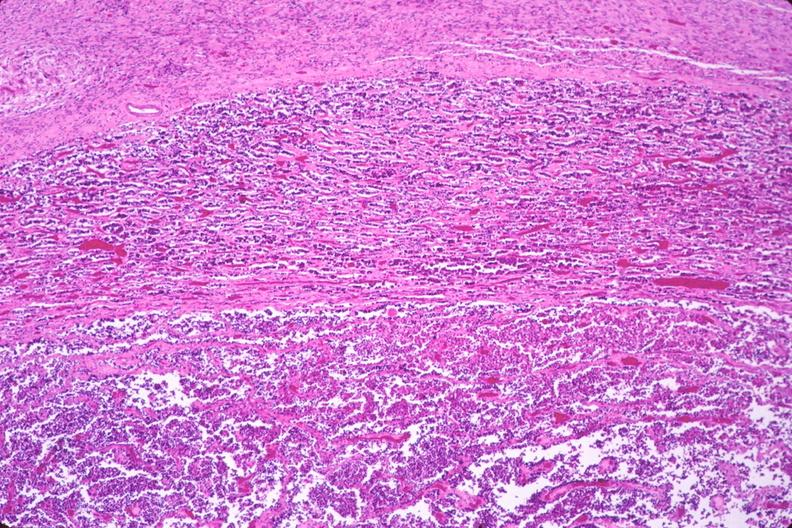does this image show pituitary, chromaphobe adenoma?
Answer the question using a single word or phrase. Yes 